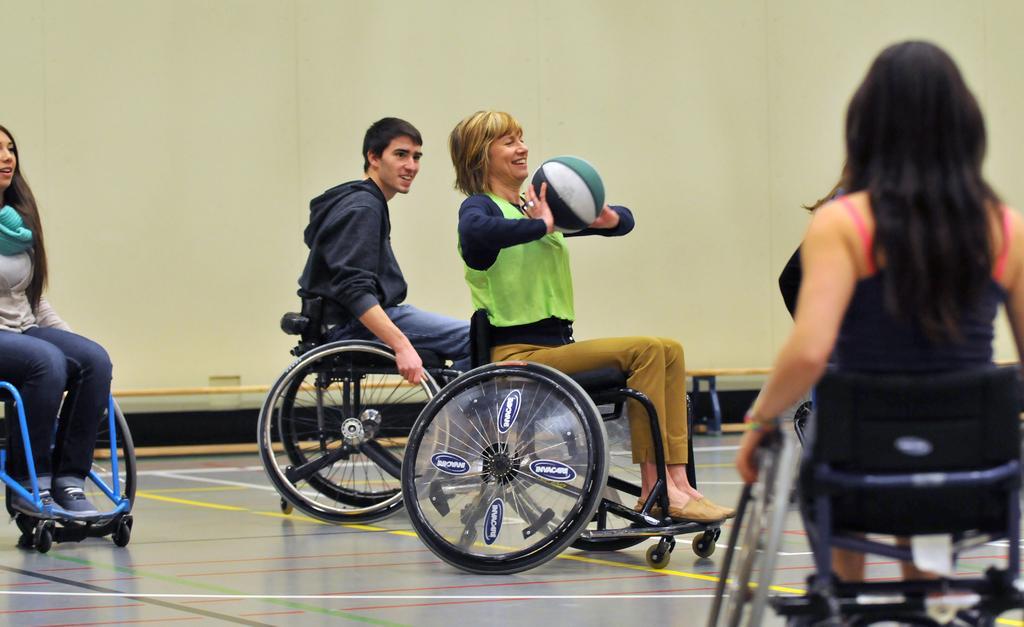In one or two sentences, can you explain what this image depicts? In this image, we can see persons wearing clothes and sitting on wheelchairs. There is a person in the middle of the image holding a ball with her hands. 